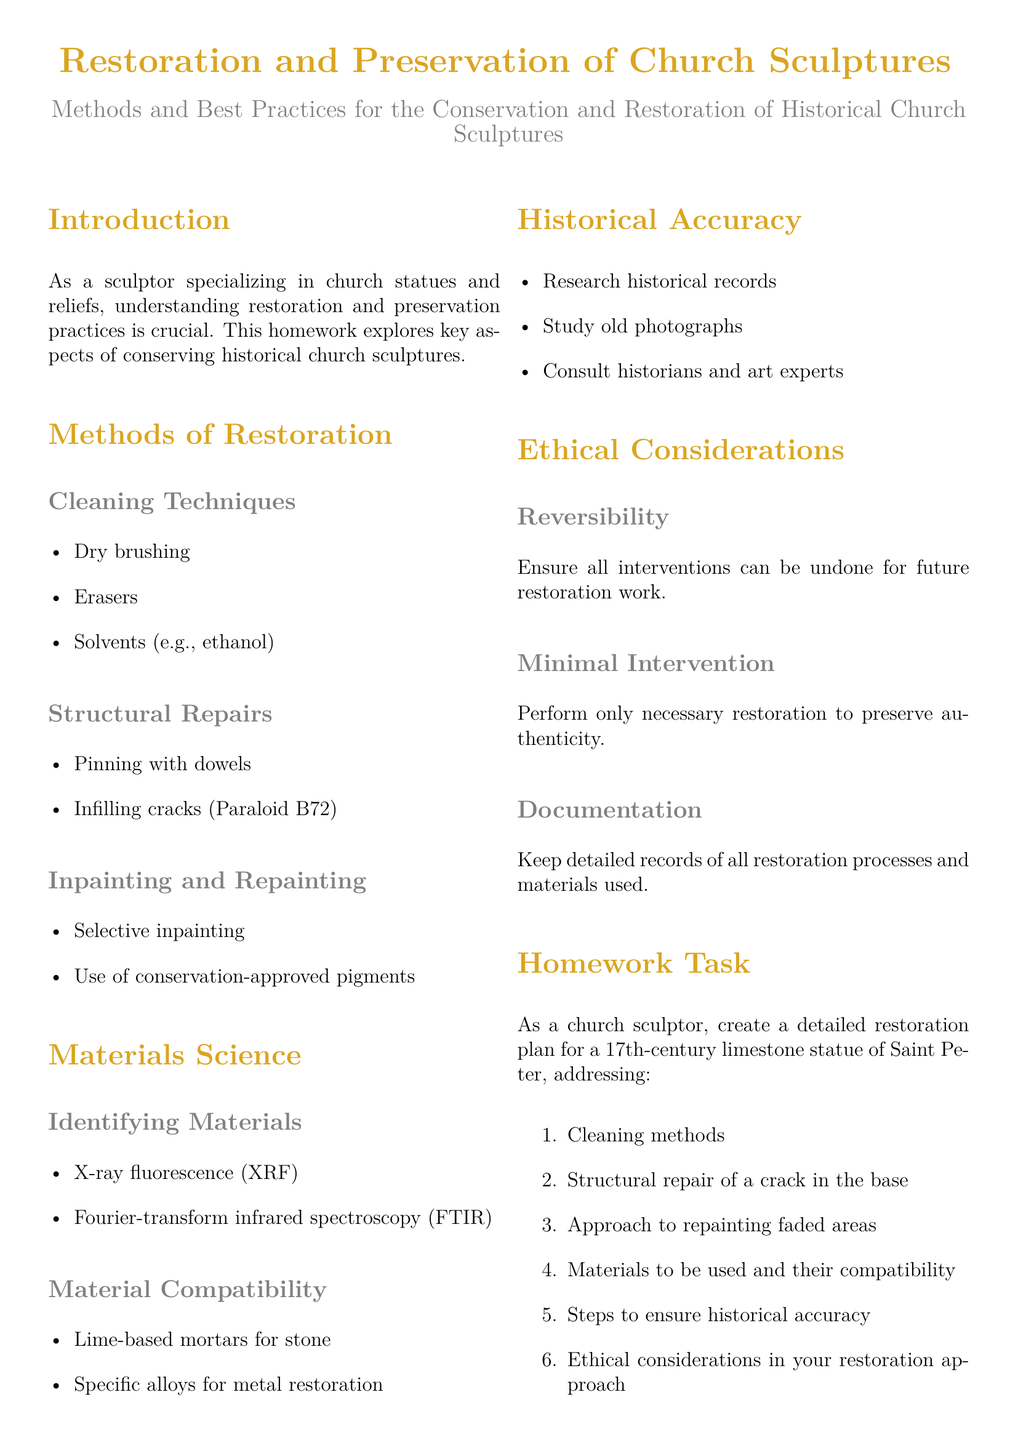What are the cleaning techniques mentioned? The document lists cleaning techniques under restoration methods, including dry brushing, erasers, and solvents such as ethanol.
Answer: Dry brushing, erasers, solvents What is used for infilling cracks? The document specifies Paraloid B72 as a material used for infilling cracks during structural repairs.
Answer: Paraloid B72 What should the documentation process include? It is mentioned that keeping detailed records of all restoration processes and materials used is essential for ethical considerations.
Answer: Detailed records Which spectroscopy is used for identifying materials? X-ray fluorescence (XRF) is highlighted as one of the methods for identifying materials in the document.
Answer: X-ray fluorescence What is the emphasis on historical accuracy? The document includes researching historical records, studying old photographs, and consulting historians and art experts as methods.
Answer: Research historical records What is the importance of reversibility in restoration? The document states that ensuring all interventions can be undone is crucial for future restoration work, reflecting ethical considerations.
Answer: Undo interventions What is indicated as a key consideration in restoration? The document emphasizes performing only necessary restoration to preserve the authenticity of the piece.
Answer: Minimal intervention What is the recommended task for the homework? The homework task requests creating a detailed restoration plan for a specific historical statue, addressing various restoration aspects.
Answer: Detailed restoration plan Which materials are suggested for metal restoration? The document discusses the use of specific alloys for metal restoration under material compatibility.
Answer: Specific alloys 